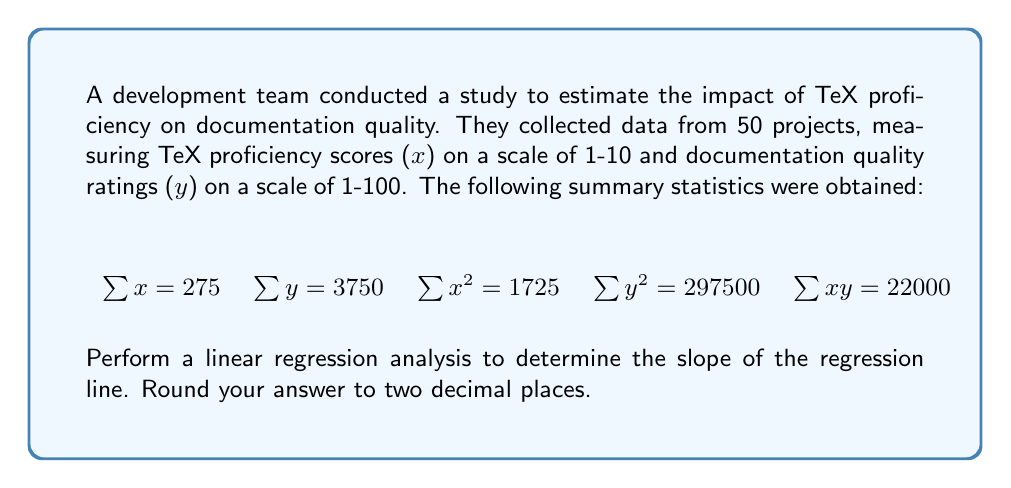Teach me how to tackle this problem. To perform linear regression and find the slope, we'll follow these steps:

1. Calculate the means of x and y:
   $\bar{x} = \frac{\sum x}{n} = \frac{275}{50} = 5.5$
   $\bar{y} = \frac{\sum y}{n} = \frac{3750}{50} = 75$

2. Calculate $S_{xx}$, $S_{yy}$, and $S_{xy}$:
   $S_{xx} = \sum x^2 - n\bar{x}^2 = 1725 - 50(5.5)^2 = 237.5$
   $S_{yy} = \sum y^2 - n\bar{y}^2 = 297500 - 50(75)^2 = 16250$
   $S_{xy} = \sum xy - n\bar{x}\bar{y} = 22000 - 50(5.5)(75) = 1375$

3. Calculate the slope (b) of the regression line:
   $$b = \frac{S_{xy}}{S_{xx}} = \frac{1375}{237.5} = 5.7894736842$$

4. Round the result to two decimal places:
   $b \approx 5.79$

The slope of 5.79 indicates that for each unit increase in TeX proficiency score, the documentation quality rating is expected to increase by approximately 5.79 points.
Answer: $5.79$ 